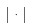<formula> <loc_0><loc_0><loc_500><loc_500>| \cdot |</formula> 